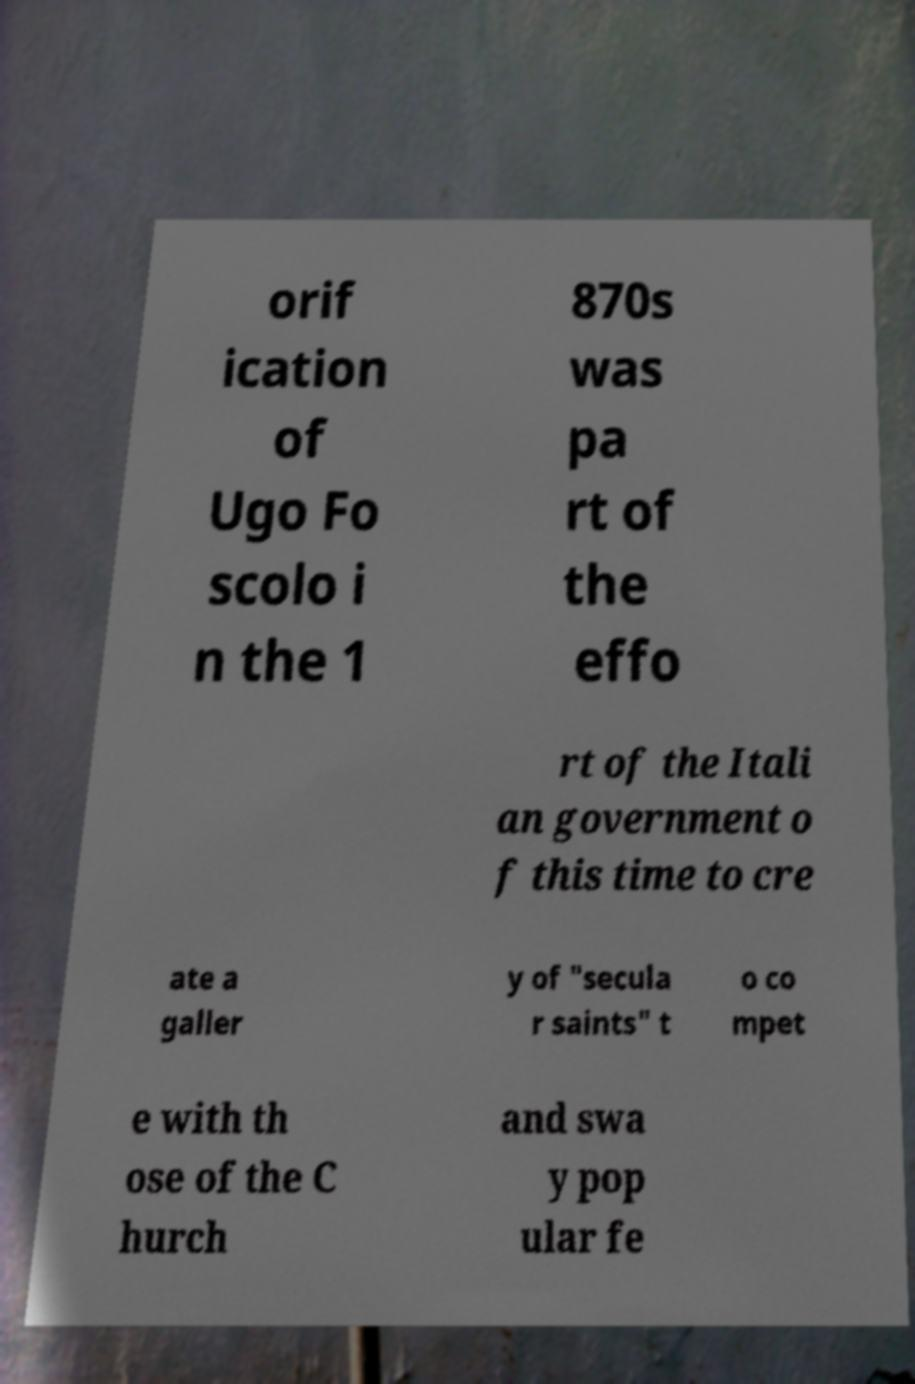For documentation purposes, I need the text within this image transcribed. Could you provide that? orif ication of Ugo Fo scolo i n the 1 870s was pa rt of the effo rt of the Itali an government o f this time to cre ate a galler y of "secula r saints" t o co mpet e with th ose of the C hurch and swa y pop ular fe 